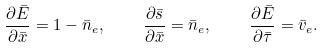Convert formula to latex. <formula><loc_0><loc_0><loc_500><loc_500>\frac { \partial \bar { E } } { \partial \bar { x } } = 1 - \bar { n } _ { e } , \quad \frac { \partial \bar { s } } { \partial \bar { x } } = \bar { n } _ { e } , \quad \frac { \partial \bar { E } } { \partial \bar { \tau } } = \bar { v } _ { e } .</formula> 